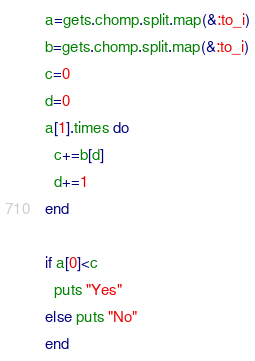<code> <loc_0><loc_0><loc_500><loc_500><_Ruby_>a=gets.chomp.split.map(&:to_i)
b=gets.chomp.split.map(&:to_i)
c=0
d=0
a[1].times do 
  c+=b[d]
  d+=1
end

if a[0]<c
  puts "Yes"
else puts "No"
end</code> 